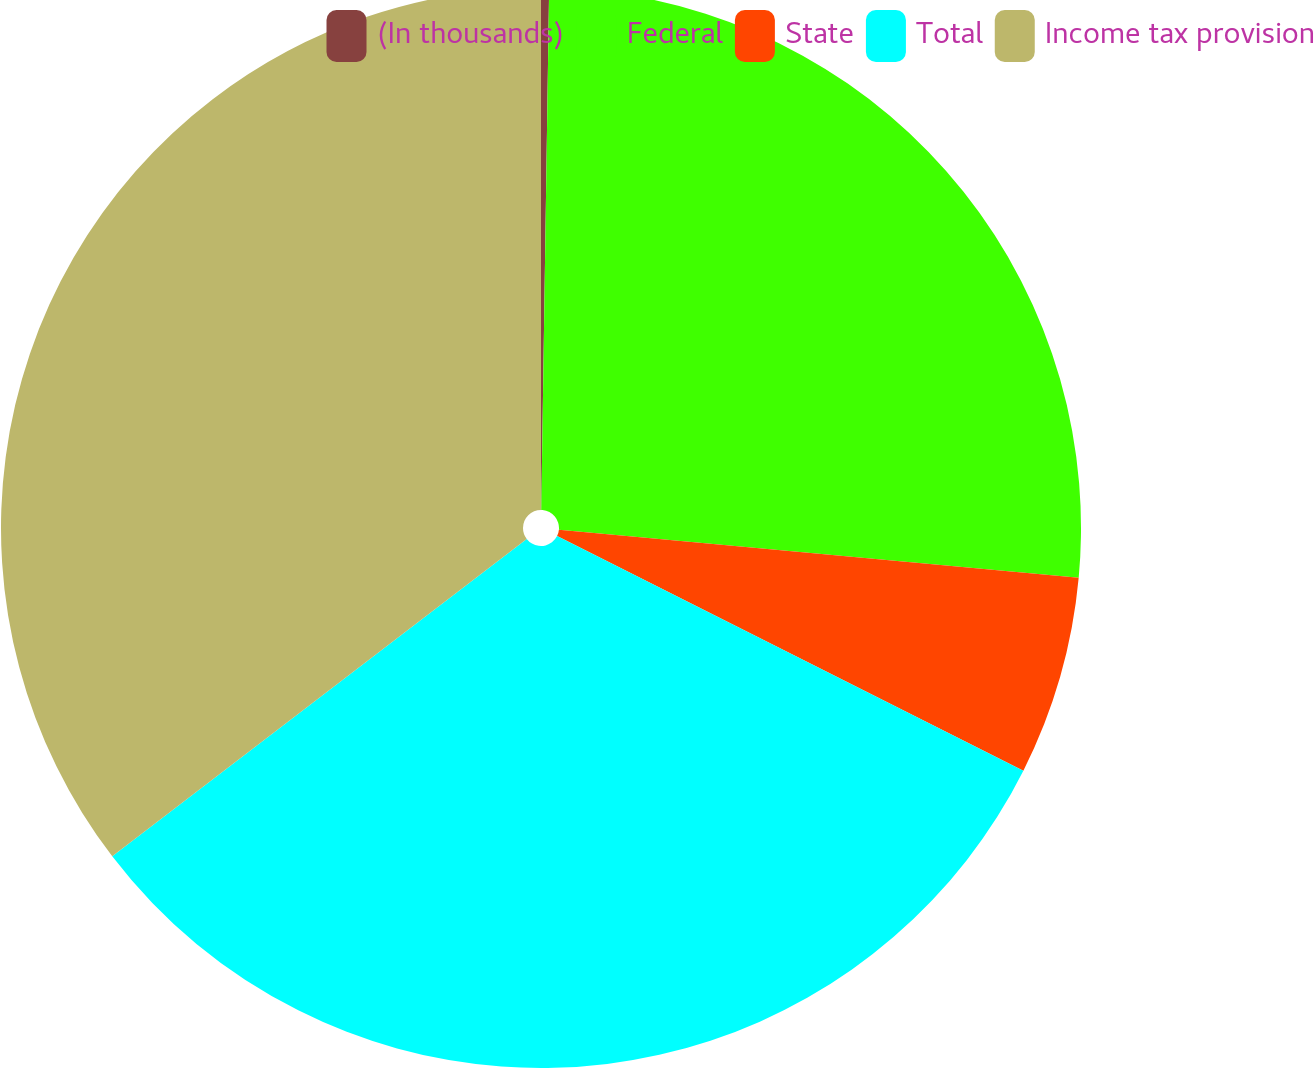<chart> <loc_0><loc_0><loc_500><loc_500><pie_chart><fcel>(In thousands)<fcel>Federal<fcel>State<fcel>Total<fcel>Income tax provision<nl><fcel>0.24%<fcel>26.23%<fcel>5.95%<fcel>32.18%<fcel>35.4%<nl></chart> 